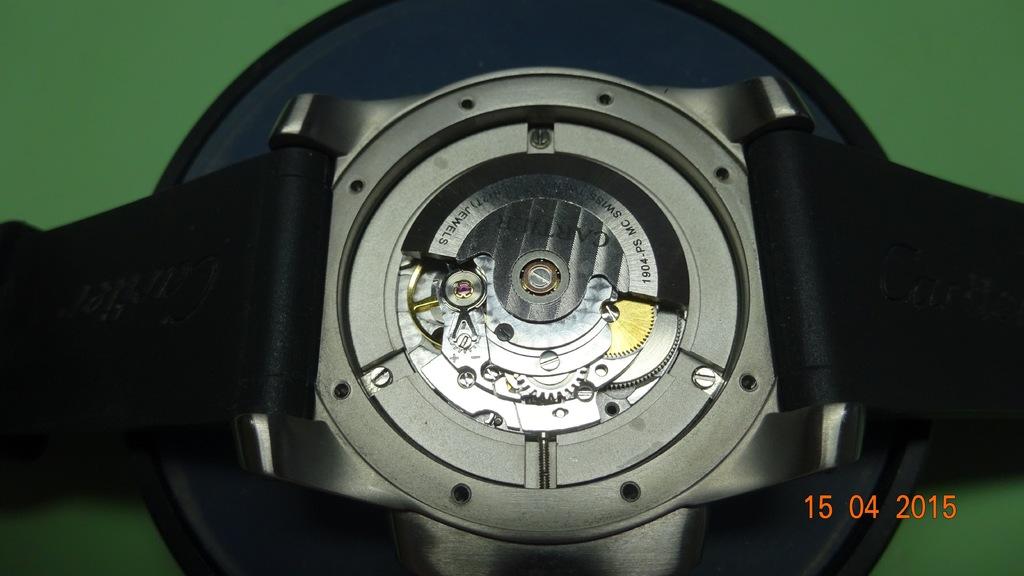What is the brand on this watch?
Provide a short and direct response. Cartier. 